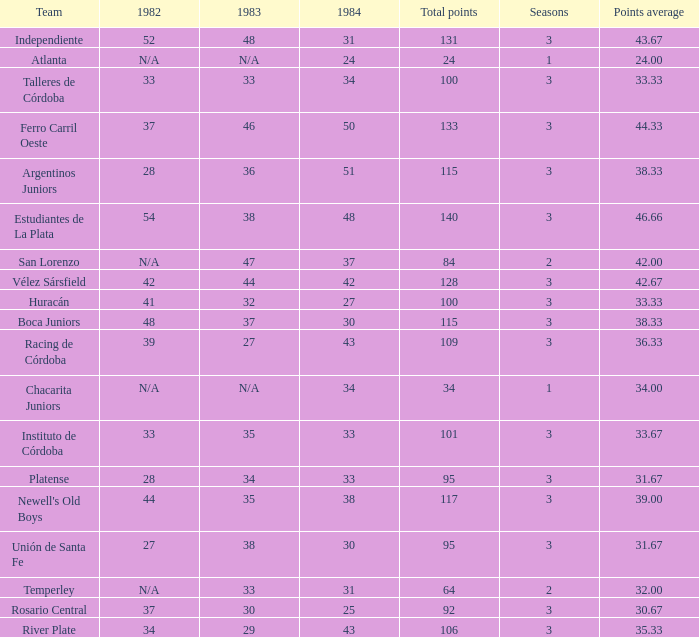What team had 3 seasons and fewer than 27 in 1984? Rosario Central. 